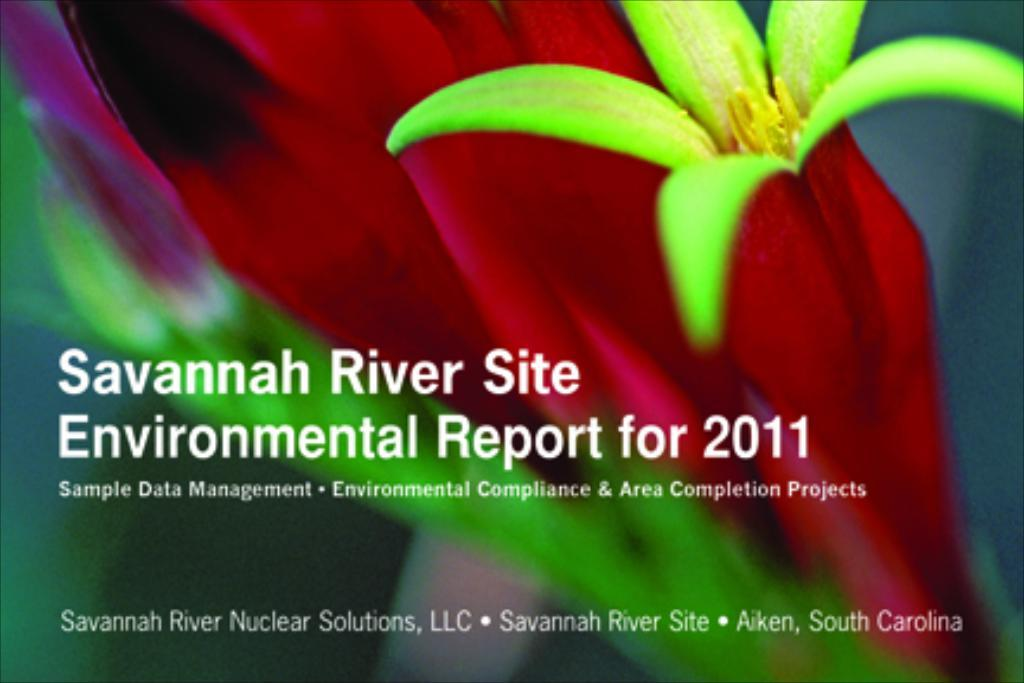What is the main subject of the image? There is a flower in the center of the image. Is there any text accompanying the flower in the image? Yes, there is some text in the image. What type of voice can be heard coming from the flower in the image? There is no voice present in the image, as it is a still image of a flower and text. 